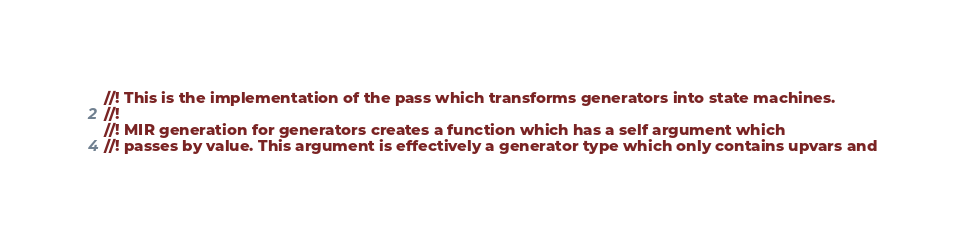<code> <loc_0><loc_0><loc_500><loc_500><_Rust_>//! This is the implementation of the pass which transforms generators into state machines.
//!
//! MIR generation for generators creates a function which has a self argument which
//! passes by value. This argument is effectively a generator type which only contains upvars and</code> 